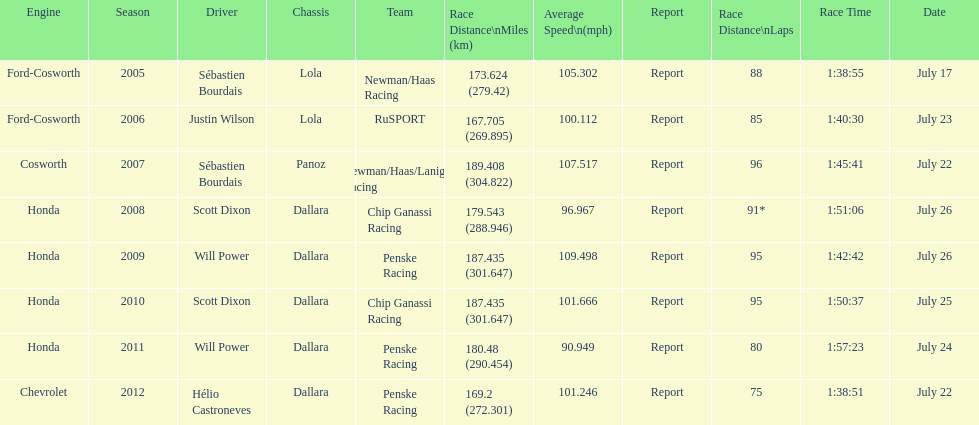What is the total number dallara chassis listed in the table? 5. 